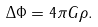<formula> <loc_0><loc_0><loc_500><loc_500>\Delta \Phi = 4 \pi G \rho .</formula> 